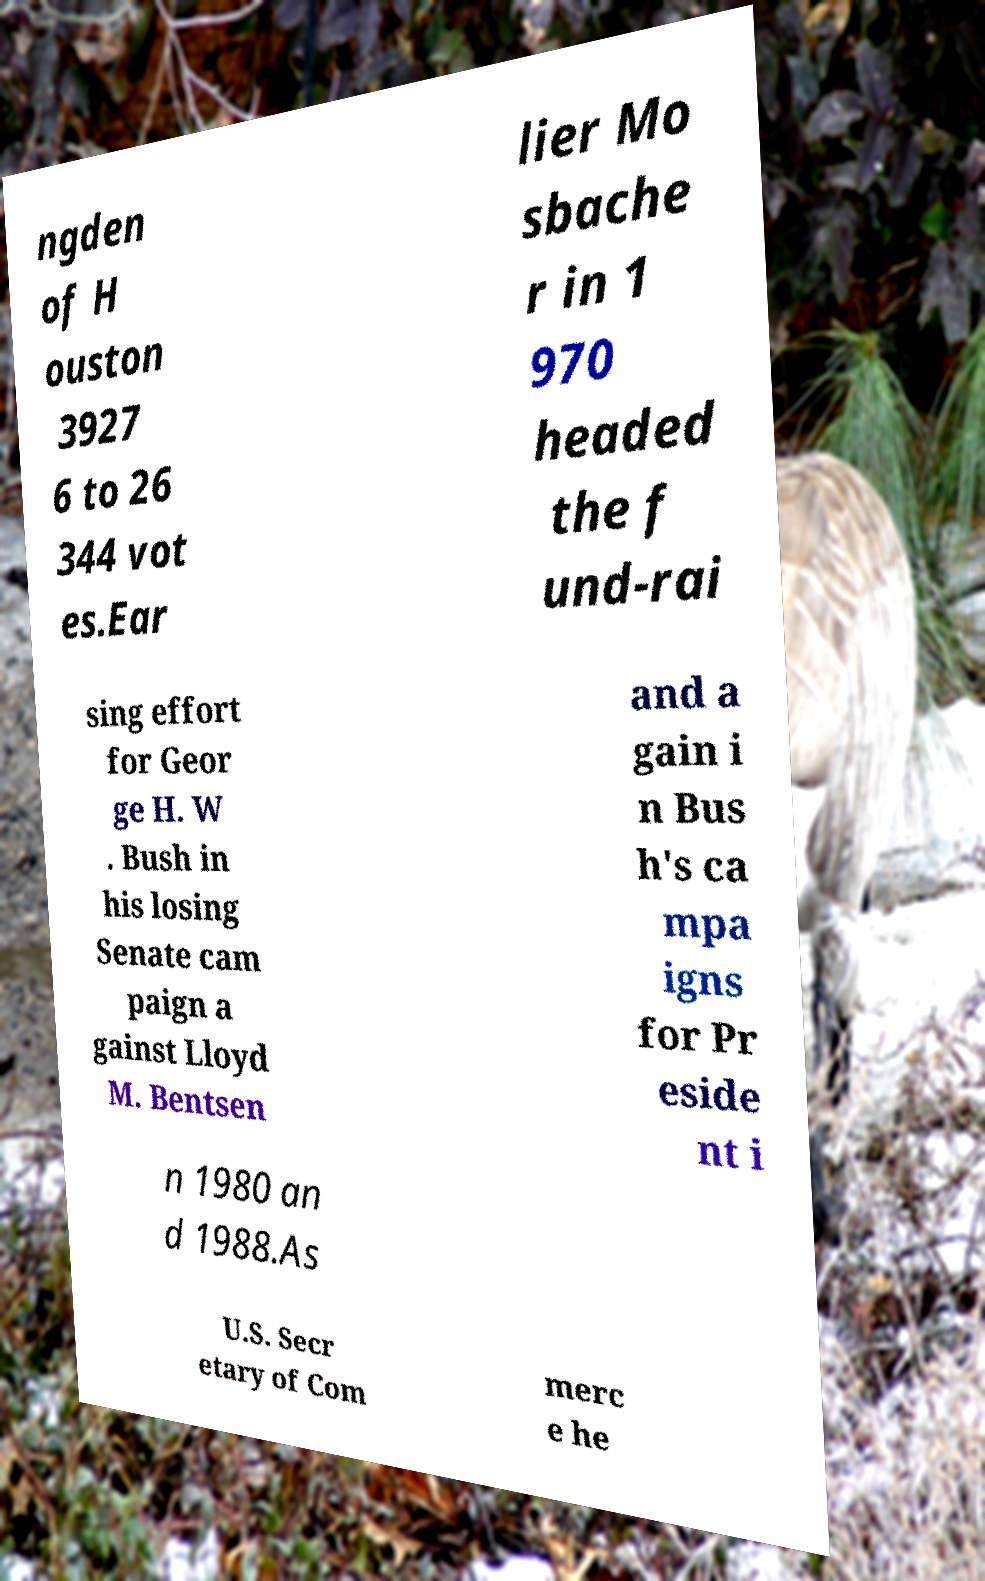Please read and relay the text visible in this image. What does it say? ngden of H ouston 3927 6 to 26 344 vot es.Ear lier Mo sbache r in 1 970 headed the f und-rai sing effort for Geor ge H. W . Bush in his losing Senate cam paign a gainst Lloyd M. Bentsen and a gain i n Bus h's ca mpa igns for Pr eside nt i n 1980 an d 1988.As U.S. Secr etary of Com merc e he 